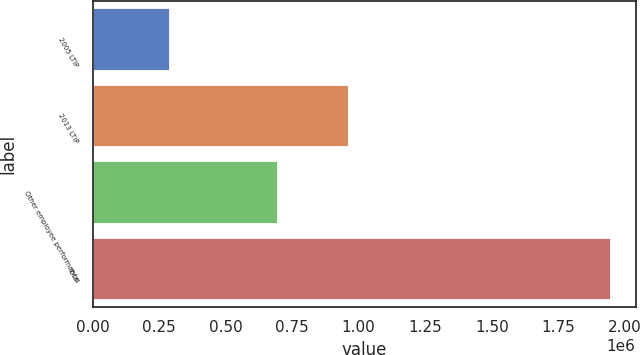Convert chart to OTSL. <chart><loc_0><loc_0><loc_500><loc_500><bar_chart><fcel>2005 LTIP<fcel>2013 LTIP<fcel>Other employee performance<fcel>Total<nl><fcel>288497<fcel>960000<fcel>695000<fcel>1.9435e+06<nl></chart> 